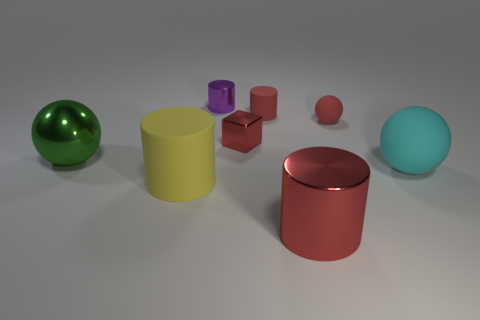Add 2 cyan cubes. How many objects exist? 10 Subtract all blocks. How many objects are left? 7 Add 7 green matte objects. How many green matte objects exist? 7 Subtract 0 blue cubes. How many objects are left? 8 Subtract all red metallic cylinders. Subtract all small red balls. How many objects are left? 6 Add 7 tiny red shiny objects. How many tiny red shiny objects are left? 8 